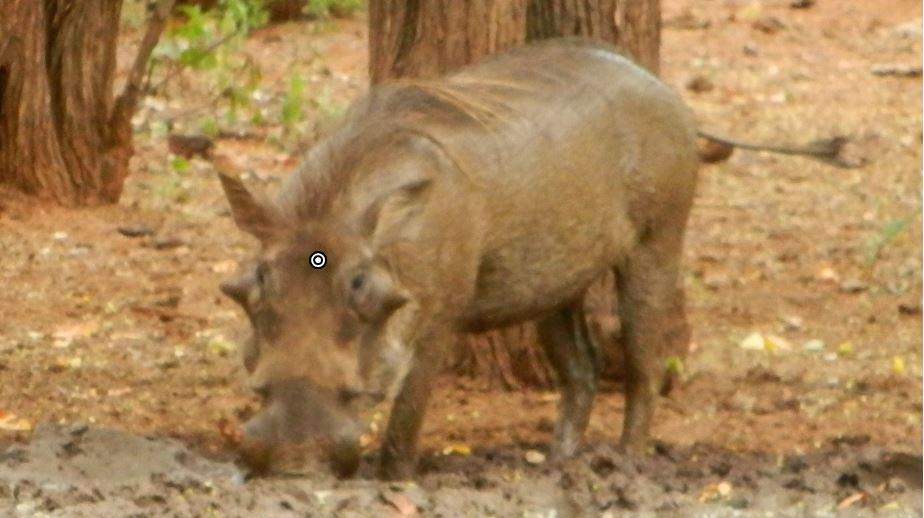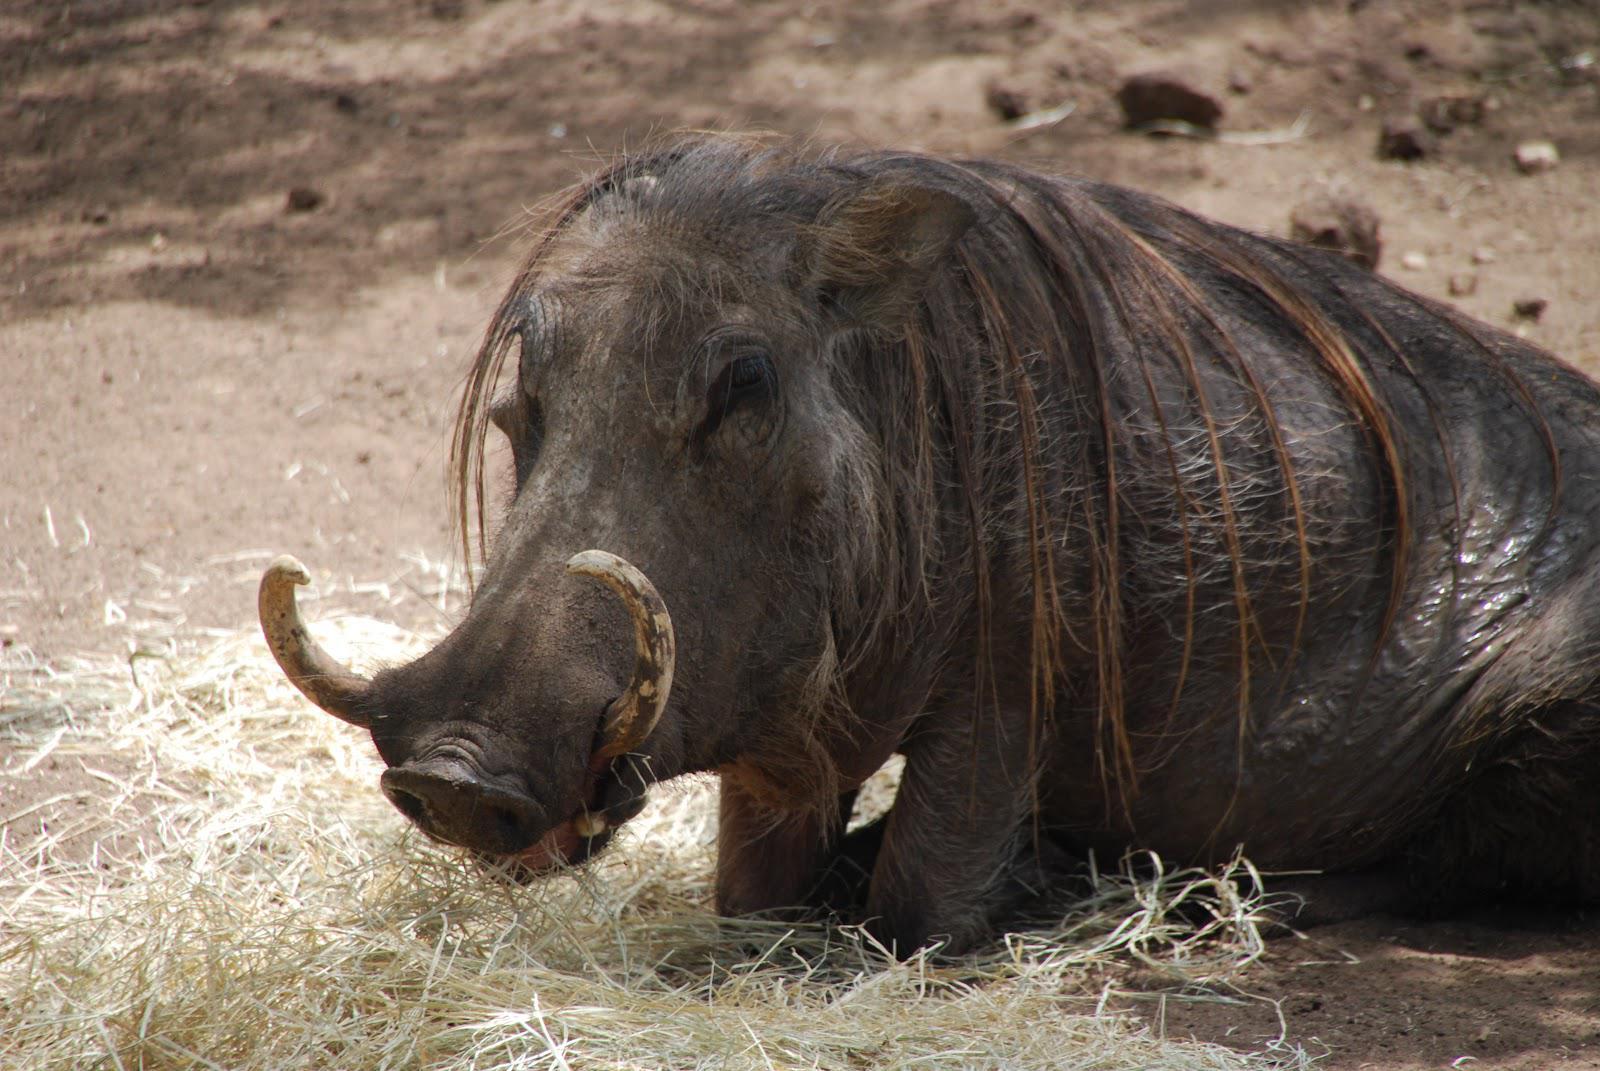The first image is the image on the left, the second image is the image on the right. Evaluate the accuracy of this statement regarding the images: "There are two hogs facing left.". Is it true? Answer yes or no. Yes. 